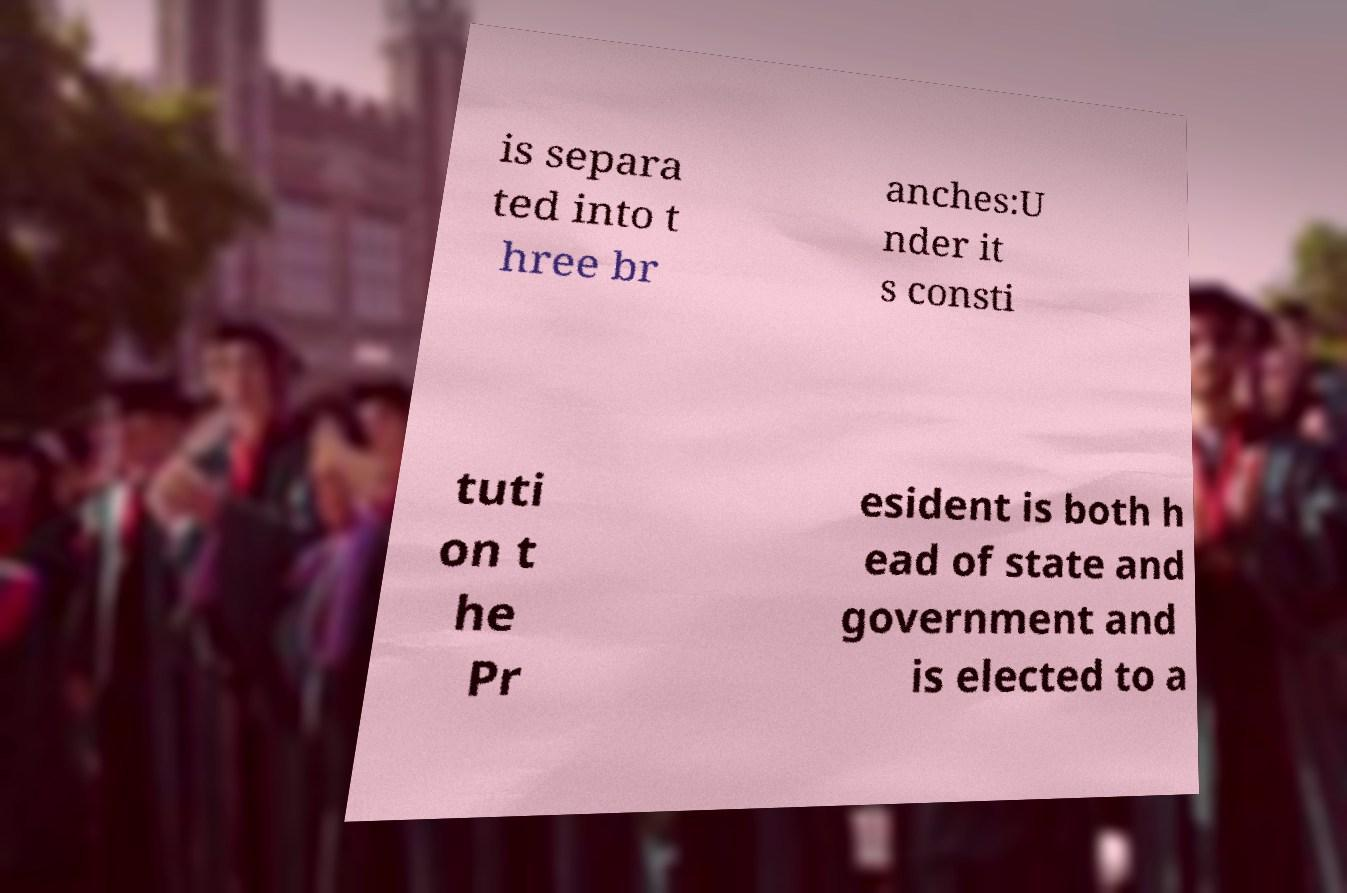There's text embedded in this image that I need extracted. Can you transcribe it verbatim? is separa ted into t hree br anches:U nder it s consti tuti on t he Pr esident is both h ead of state and government and is elected to a 